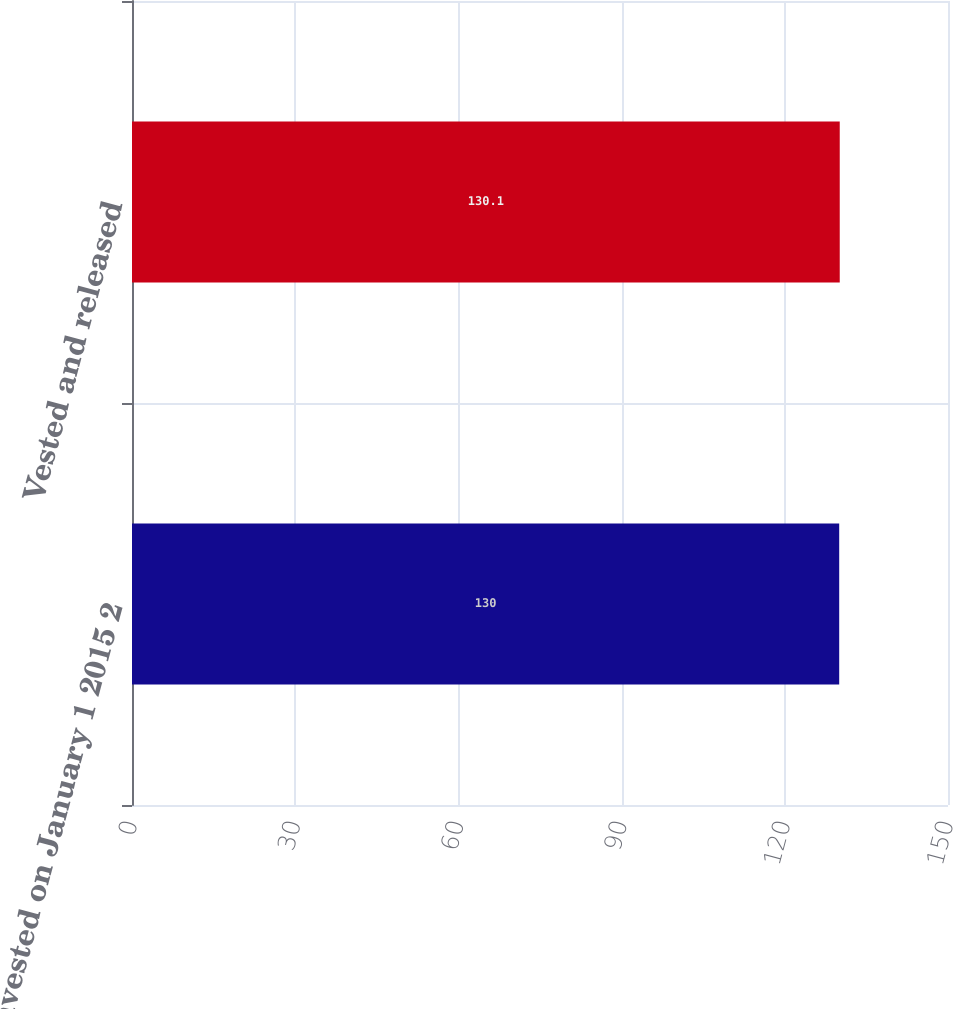Convert chart to OTSL. <chart><loc_0><loc_0><loc_500><loc_500><bar_chart><fcel>Nonvested on January 1 2015 2<fcel>Vested and released<nl><fcel>130<fcel>130.1<nl></chart> 